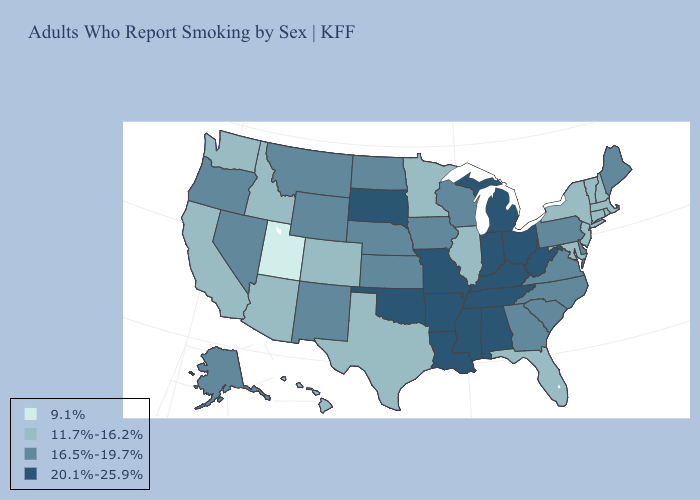Does Oklahoma have the highest value in the USA?
Keep it brief. Yes. Name the states that have a value in the range 9.1%?
Keep it brief. Utah. Name the states that have a value in the range 9.1%?
Concise answer only. Utah. Name the states that have a value in the range 9.1%?
Short answer required. Utah. Does Maryland have the lowest value in the South?
Write a very short answer. Yes. What is the highest value in the USA?
Answer briefly. 20.1%-25.9%. Among the states that border Wisconsin , which have the lowest value?
Quick response, please. Illinois, Minnesota. Name the states that have a value in the range 11.7%-16.2%?
Give a very brief answer. Arizona, California, Colorado, Connecticut, Florida, Hawaii, Idaho, Illinois, Maryland, Massachusetts, Minnesota, New Hampshire, New Jersey, New York, Rhode Island, Texas, Vermont, Washington. Does North Dakota have the same value as New Jersey?
Concise answer only. No. Does Maine have the lowest value in the Northeast?
Be succinct. No. Does Indiana have the lowest value in the USA?
Answer briefly. No. Which states have the lowest value in the South?
Short answer required. Florida, Maryland, Texas. Does the first symbol in the legend represent the smallest category?
Write a very short answer. Yes. What is the value of Louisiana?
Short answer required. 20.1%-25.9%. Which states hav the highest value in the South?
Be succinct. Alabama, Arkansas, Kentucky, Louisiana, Mississippi, Oklahoma, Tennessee, West Virginia. 